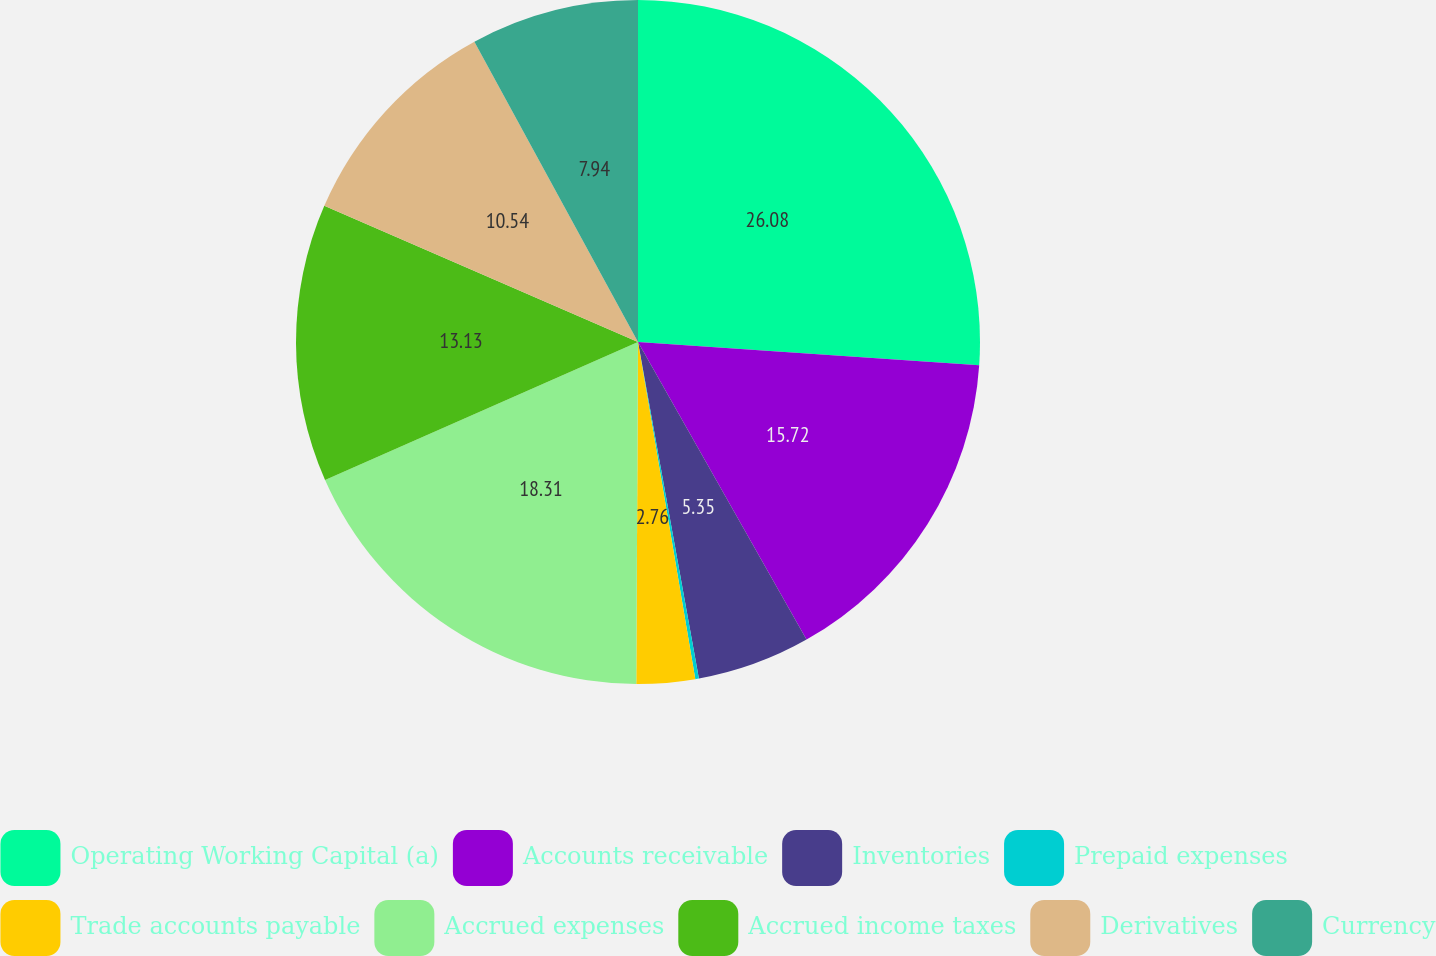<chart> <loc_0><loc_0><loc_500><loc_500><pie_chart><fcel>Operating Working Capital (a)<fcel>Accounts receivable<fcel>Inventories<fcel>Prepaid expenses<fcel>Trade accounts payable<fcel>Accrued expenses<fcel>Accrued income taxes<fcel>Derivatives<fcel>Currency<nl><fcel>26.08%<fcel>15.72%<fcel>5.35%<fcel>0.17%<fcel>2.76%<fcel>18.31%<fcel>13.13%<fcel>10.54%<fcel>7.94%<nl></chart> 